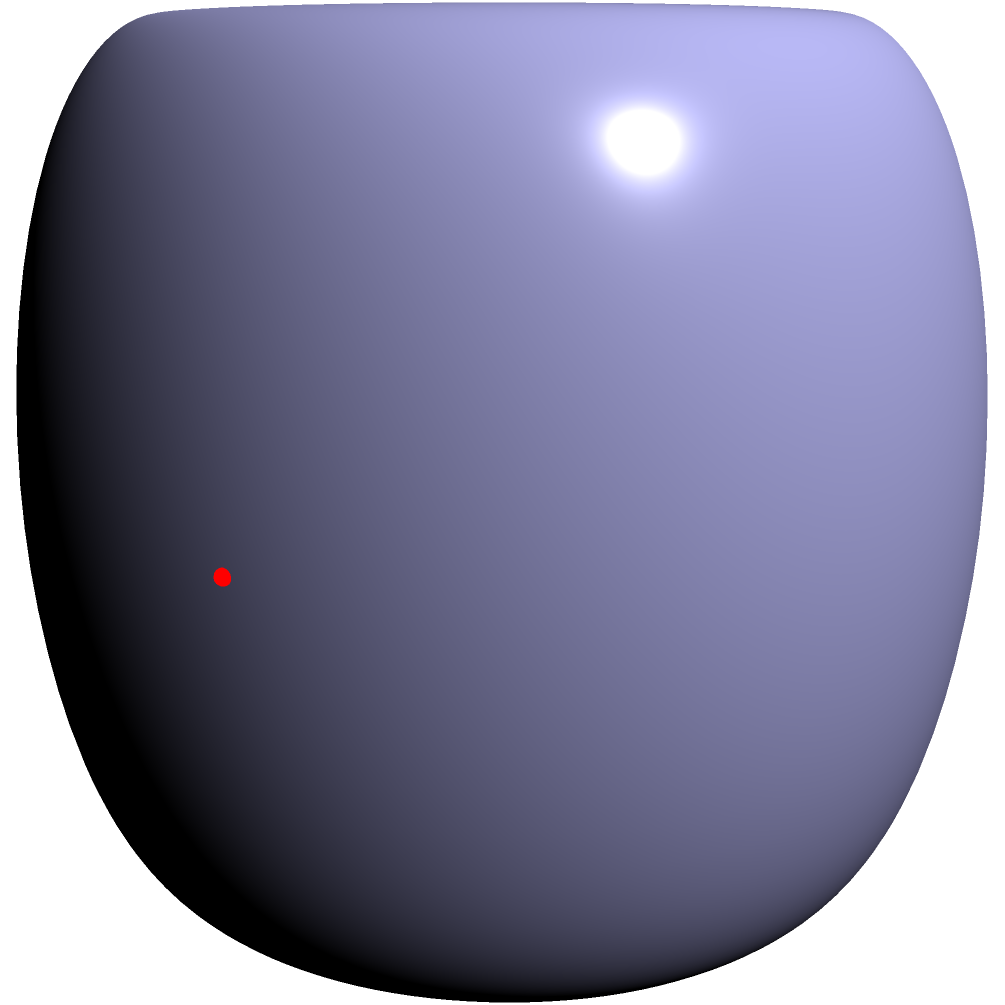In a culinary documentary, you're recording audio on a toroidal set. Two microphones are placed at points A and B on the torus as shown. The major radius (R) of the torus is 2 meters, and the minor radius (r) is 1 meter. If sound travels along the surface of the torus, what is the shortest distance between the microphones measured along the surface? To solve this problem, we need to understand the geometry of a torus and how to measure distances on its surface. Let's break it down step-by-step:

1) The torus is defined by two radii:
   - Major radius (R) = 2 meters (distance from the center of the tube to the center of the torus)
   - Minor radius (r) = 1 meter (radius of the tube)

2) Point A is located at (R+r, 0, 0) in Cartesian coordinates.
   Point B is located at (R, r, 0).

3) The shortest path between two points on a torus is not always a straight line in 3D space. It depends on the relative positions of the points.

4) In this case, the shortest path will be along the outer circumference of the torus (where y=0 in our parametric equation).

5) To find the arc length, we need to find the angle subtended at the center:
   $$\theta = \arccos(\frac{R}{R+r}) = \arccos(\frac{2}{3}) \approx 0.8411 \text{ radians}$$

6) The arc length is then:
   $$s = (R+r) \theta = 3 \cdot 0.8411 \approx 2.5233 \text{ meters}$$

This is the shortest distance between the microphones measured along the surface of the torus.
Answer: 2.5233 meters 